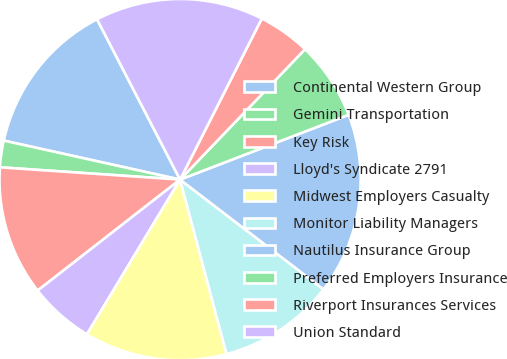Convert chart. <chart><loc_0><loc_0><loc_500><loc_500><pie_chart><fcel>Continental Western Group<fcel>Gemini Transportation<fcel>Key Risk<fcel>Lloyd's Syndicate 2791<fcel>Midwest Employers Casualty<fcel>Monitor Liability Managers<fcel>Nautilus Insurance Group<fcel>Preferred Employers Insurance<fcel>Riverport Insurances Services<fcel>Union Standard<nl><fcel>13.93%<fcel>2.38%<fcel>11.62%<fcel>5.84%<fcel>12.77%<fcel>10.46%<fcel>16.24%<fcel>7.0%<fcel>4.69%<fcel>15.08%<nl></chart> 